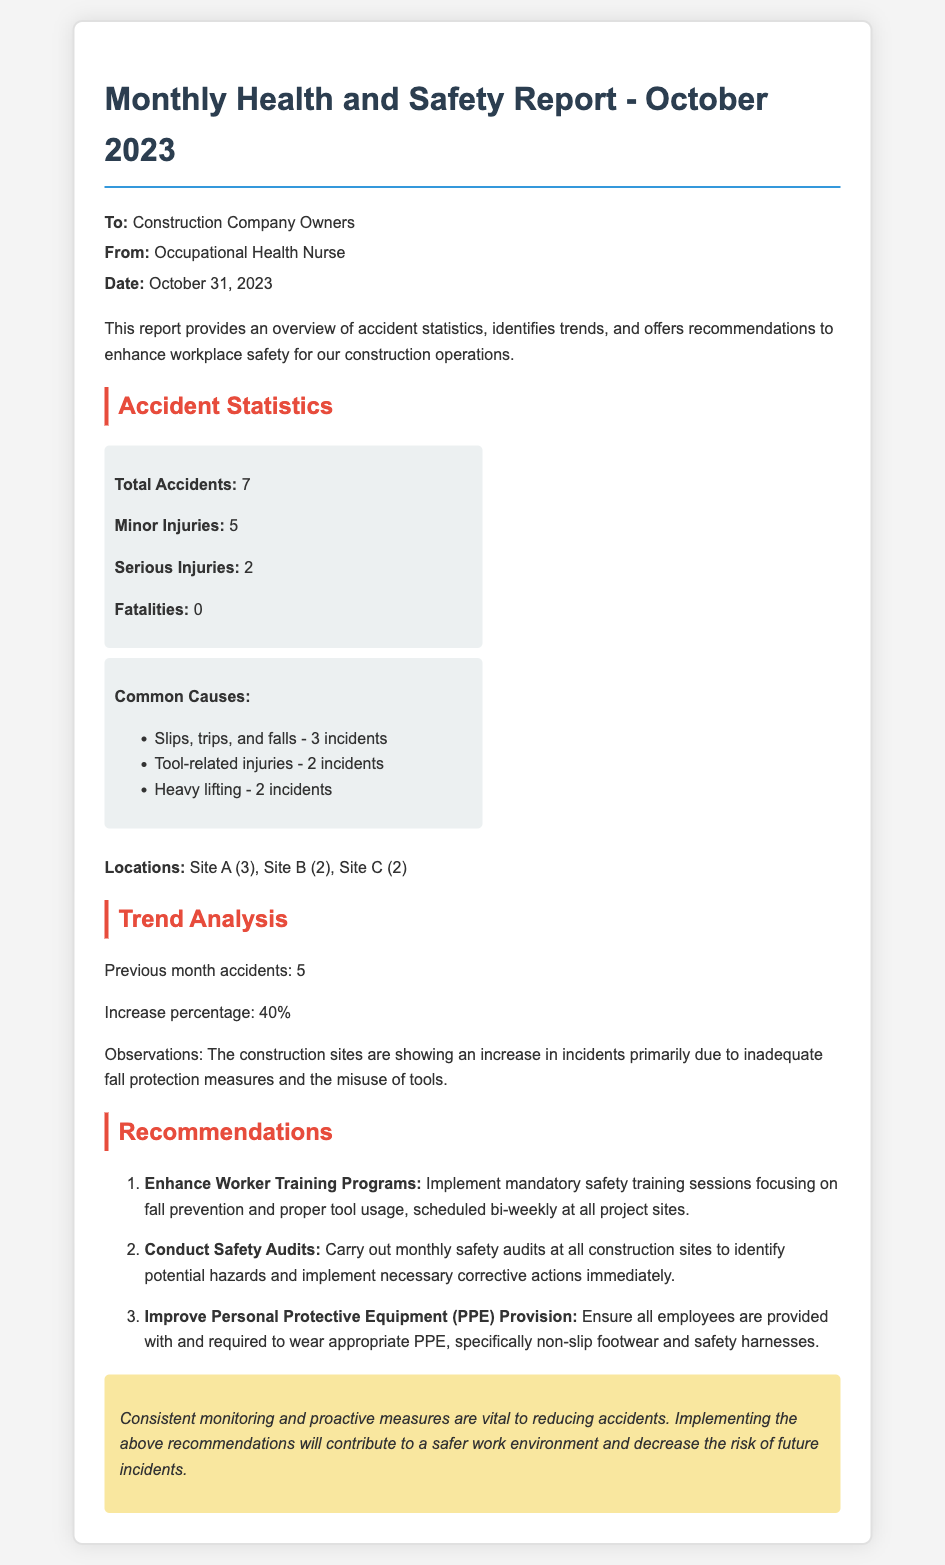What is the total number of accidents? The total number of accidents is highlighted in the statistics section of the report.
Answer: 7 What were the serious injuries reported? Serious injuries are specified in the accident statistics within the report.
Answer: 2 What is the primary reason for the increase in incidents? The report mentions observations regarding the increase in incidents due to specific causes.
Answer: Inadequate fall protection measures How many locations reported accidents? The report lists the locations where accidents occurred and their respective counts.
Answer: 3 If the previous month's accidents were 5, what is the increase percentage? The increase percentage is calculated based on the comparison of this month’s and last month’s accidents in the trend analysis section.
Answer: 40% What type of training programs are recommended? The report contains recommendations emphasizing specific training types to improve safety.
Answer: Mandatory safety training sessions How many recommendations are provided in the report? The report's section on recommendations lists the number of points made to enhance safety.
Answer: 3 What is the main focus of the safety audits? The recommendations section details the purpose of conducting safety audits in the construction sites.
Answer: Identify potential hazards What personal protective equipment is specifically mentioned? The recommendations part highlights specific PPE that should be provided to employees.
Answer: Non-slip footwear and safety harnesses 